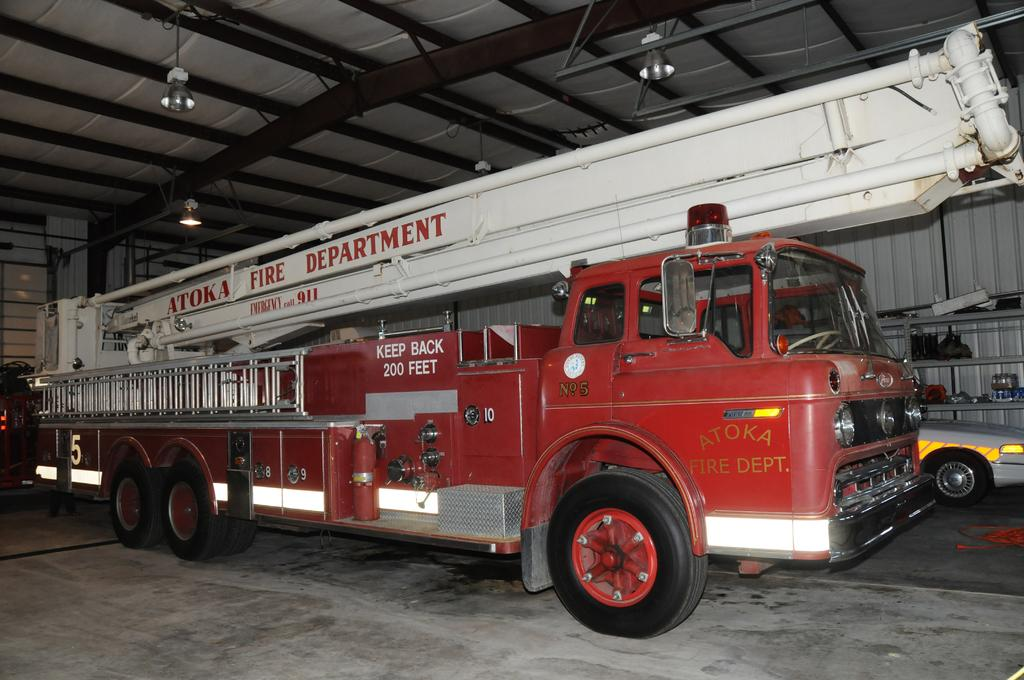What is the main subject of the image? The main subject of the image is a fire engine. Where is the fire engine located in the image? The fire engine is inside a godown. What type of lighting is present in the image? There are lights over the ceiling in the image. What type of heart-shaped coil can be seen on the fire engine in the image? There is no heart-shaped coil present on the fire engine in the image. 